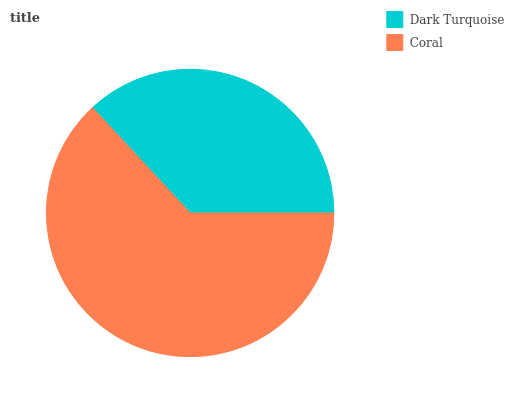Is Dark Turquoise the minimum?
Answer yes or no. Yes. Is Coral the maximum?
Answer yes or no. Yes. Is Coral the minimum?
Answer yes or no. No. Is Coral greater than Dark Turquoise?
Answer yes or no. Yes. Is Dark Turquoise less than Coral?
Answer yes or no. Yes. Is Dark Turquoise greater than Coral?
Answer yes or no. No. Is Coral less than Dark Turquoise?
Answer yes or no. No. Is Coral the high median?
Answer yes or no. Yes. Is Dark Turquoise the low median?
Answer yes or no. Yes. Is Dark Turquoise the high median?
Answer yes or no. No. Is Coral the low median?
Answer yes or no. No. 